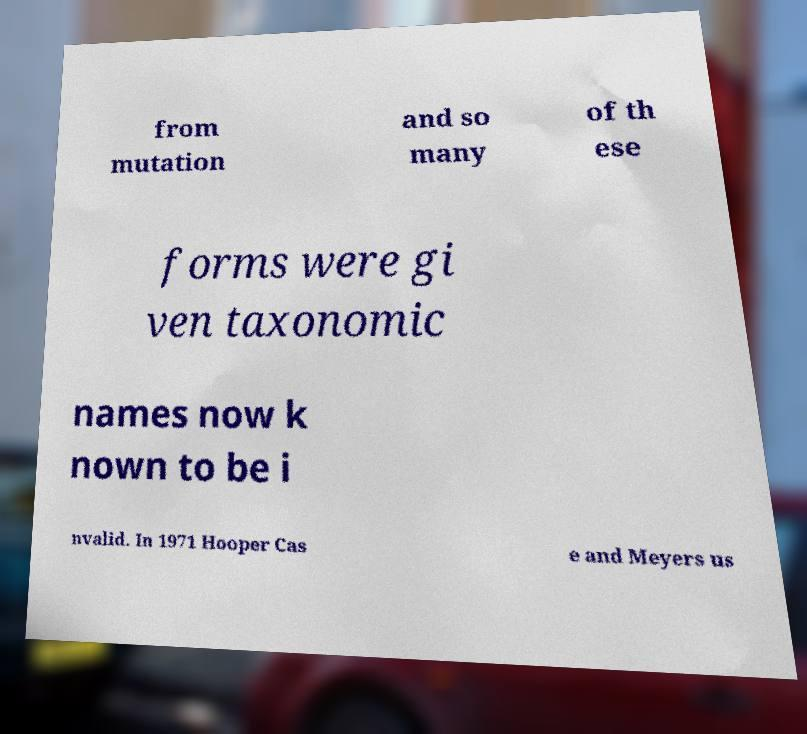Can you read and provide the text displayed in the image?This photo seems to have some interesting text. Can you extract and type it out for me? from mutation and so many of th ese forms were gi ven taxonomic names now k nown to be i nvalid. In 1971 Hooper Cas e and Meyers us 